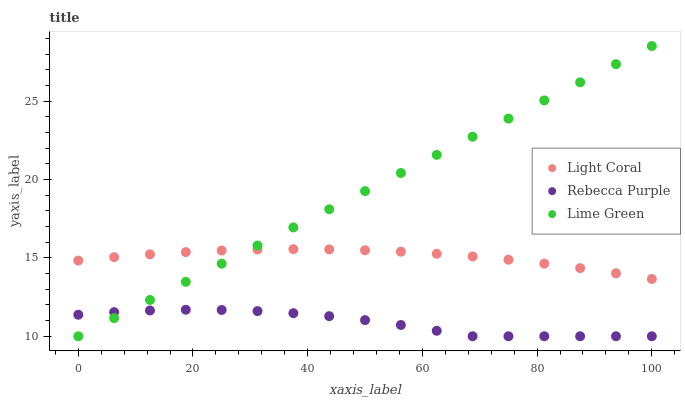Does Rebecca Purple have the minimum area under the curve?
Answer yes or no. Yes. Does Lime Green have the maximum area under the curve?
Answer yes or no. Yes. Does Lime Green have the minimum area under the curve?
Answer yes or no. No. Does Rebecca Purple have the maximum area under the curve?
Answer yes or no. No. Is Lime Green the smoothest?
Answer yes or no. Yes. Is Rebecca Purple the roughest?
Answer yes or no. Yes. Is Rebecca Purple the smoothest?
Answer yes or no. No. Is Lime Green the roughest?
Answer yes or no. No. Does Lime Green have the lowest value?
Answer yes or no. Yes. Does Lime Green have the highest value?
Answer yes or no. Yes. Does Rebecca Purple have the highest value?
Answer yes or no. No. Is Rebecca Purple less than Light Coral?
Answer yes or no. Yes. Is Light Coral greater than Rebecca Purple?
Answer yes or no. Yes. Does Lime Green intersect Rebecca Purple?
Answer yes or no. Yes. Is Lime Green less than Rebecca Purple?
Answer yes or no. No. Is Lime Green greater than Rebecca Purple?
Answer yes or no. No. Does Rebecca Purple intersect Light Coral?
Answer yes or no. No. 